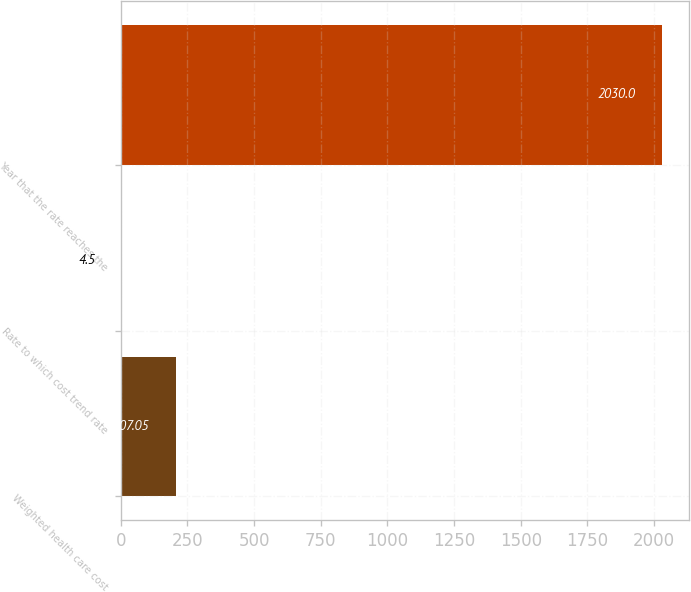Convert chart to OTSL. <chart><loc_0><loc_0><loc_500><loc_500><bar_chart><fcel>Weighted health care cost<fcel>Rate to which cost trend rate<fcel>Year that the rate reaches the<nl><fcel>207.05<fcel>4.5<fcel>2030<nl></chart> 